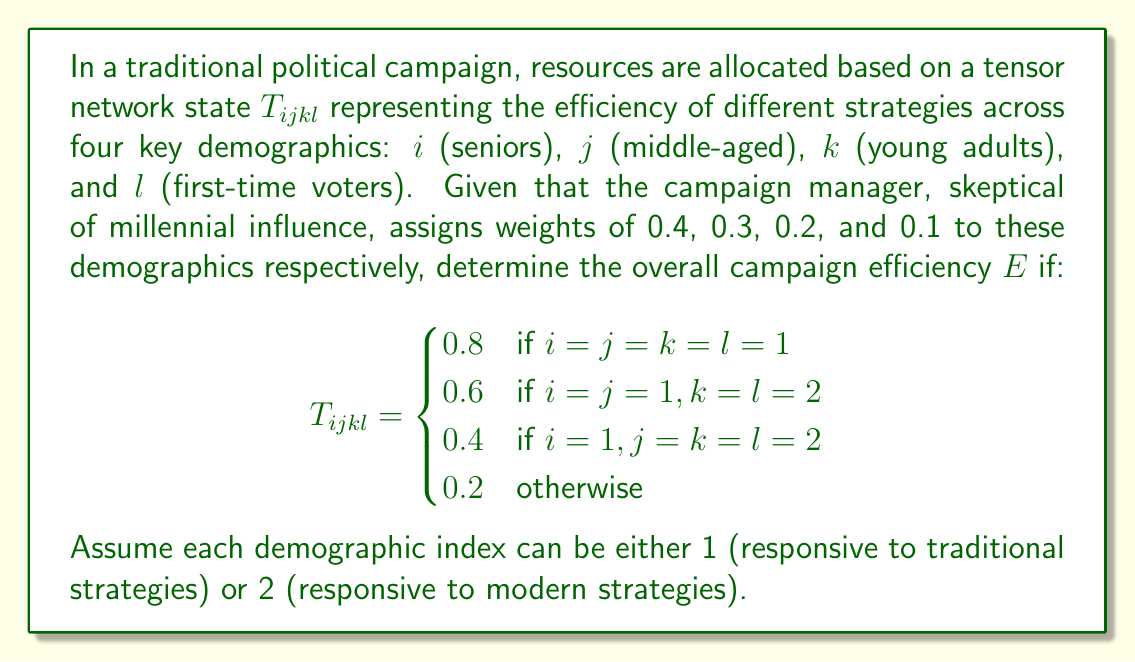Help me with this question. To solve this problem, we need to calculate the weighted sum of the tensor elements based on the given weights for each demographic. Let's break it down step-by-step:

1) First, let's identify all possible combinations of i, j, k, and l, and their corresponding tensor values:

   $T_{1111} = 0.8$
   $T_{1122} = 0.6$
   $T_{1222} = 0.4$
   All other combinations = 0.2

2) Now, we need to multiply each tensor value by the product of the corresponding demographic weights and sum them up. The weights are:

   $w_i = 0.4$ (seniors)
   $w_j = 0.3$ (middle-aged)
   $w_k = 0.2$ (young adults)
   $w_l = 0.1$ (first-time voters)

3) Let's calculate the efficiency for each combination:

   $E_{1111} = 0.8 \times 0.4 \times 0.3 \times 0.2 \times 0.1 = 0.00192$
   $E_{1122} = 0.6 \times 0.4 \times 0.3 \times 0.2 \times 0.1 = 0.00144$
   $E_{1222} = 0.4 \times 0.4 \times 0.3 \times 0.2 \times 0.1 = 0.00096$

4) For all other combinations (12 in total), the efficiency would be:

   $E_{others} = 0.2 \times 0.4 \times 0.3 \times 0.2 \times 0.1 = 0.00048$ each

5) The overall efficiency $E$ is the sum of all these values:

   $E = 0.00192 + 0.00144 + 0.00096 + (12 \times 0.00048)$
   
   $E = 0.00192 + 0.00144 + 0.00096 + 0.00576$
   
   $E = 0.01008$

Therefore, the overall campaign efficiency is 0.01008 or approximately 1.01%.
Answer: $E = 0.01008$ 